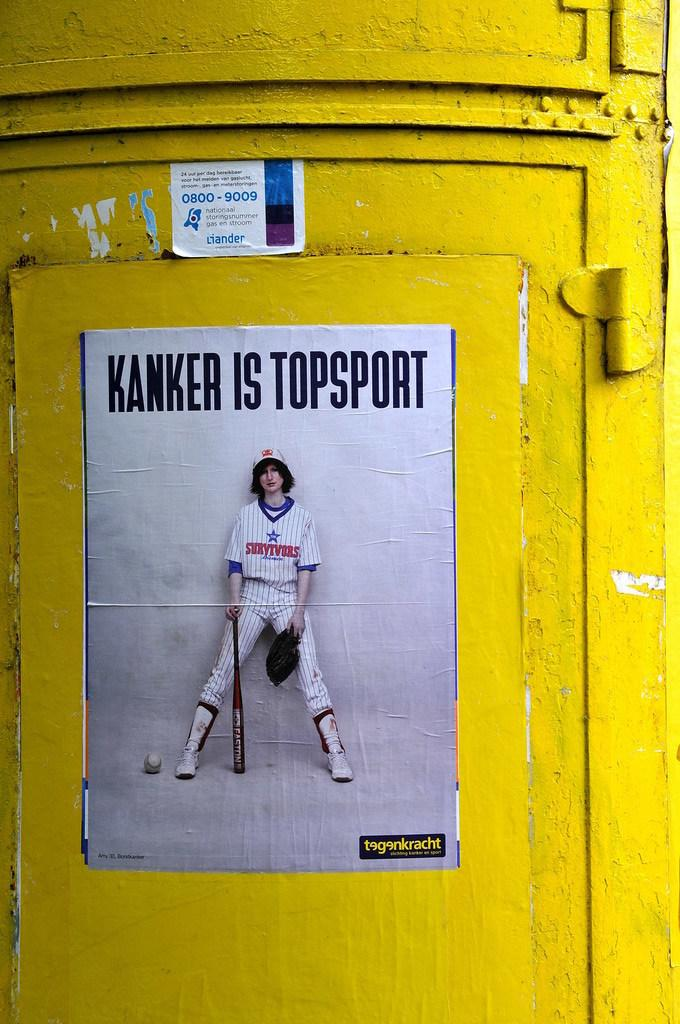Provide a one-sentence caption for the provided image. A baseball poster with the words "Kanker is Topsport." printed on a tellow pole. 